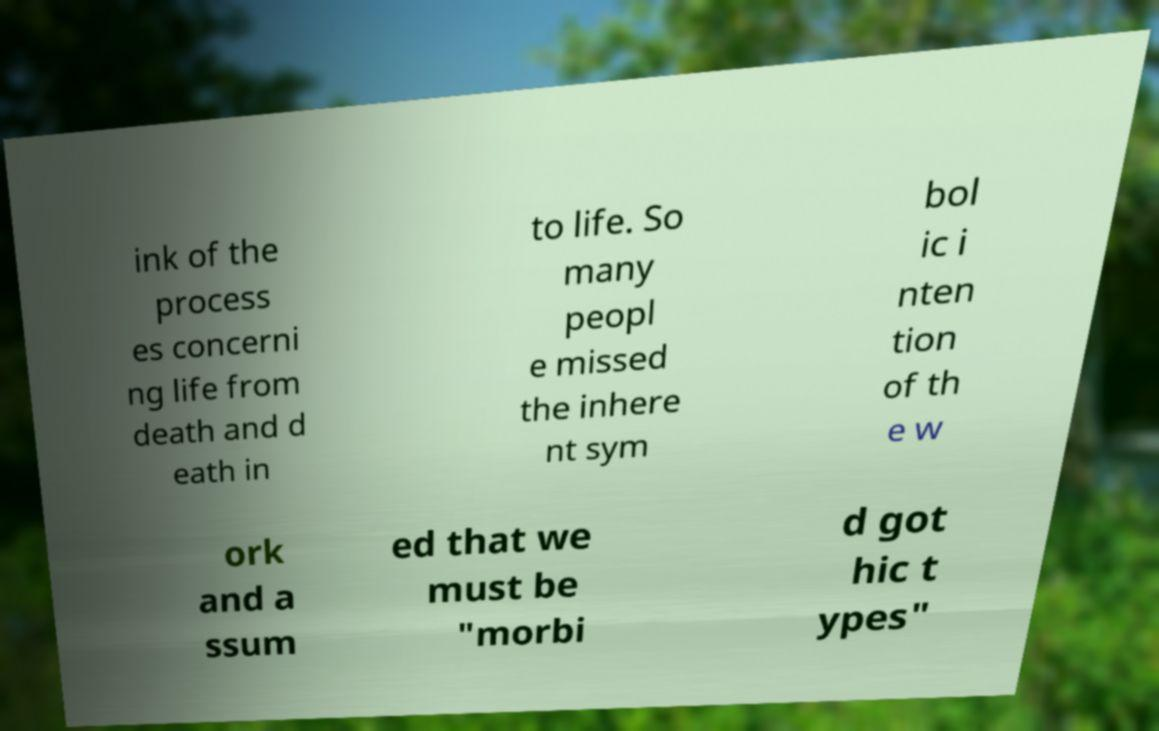I need the written content from this picture converted into text. Can you do that? ink of the process es concerni ng life from death and d eath in to life. So many peopl e missed the inhere nt sym bol ic i nten tion of th e w ork and a ssum ed that we must be "morbi d got hic t ypes" 